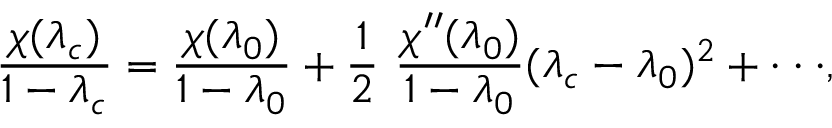<formula> <loc_0><loc_0><loc_500><loc_500>{ \frac { \chi ( \lambda _ { c } ) } { 1 - \lambda _ { c } } } = { \frac { \chi ( \lambda _ { 0 } ) } { 1 - \lambda _ { 0 } } } + { \frac { 1 } { 2 } } \ { \frac { \chi ^ { \prime \prime } ( \lambda _ { 0 } ) } { 1 - \lambda _ { 0 } } } ( \lambda _ { c } - \lambda _ { 0 } ) ^ { 2 } + \cdot \cdot \cdot ,</formula> 